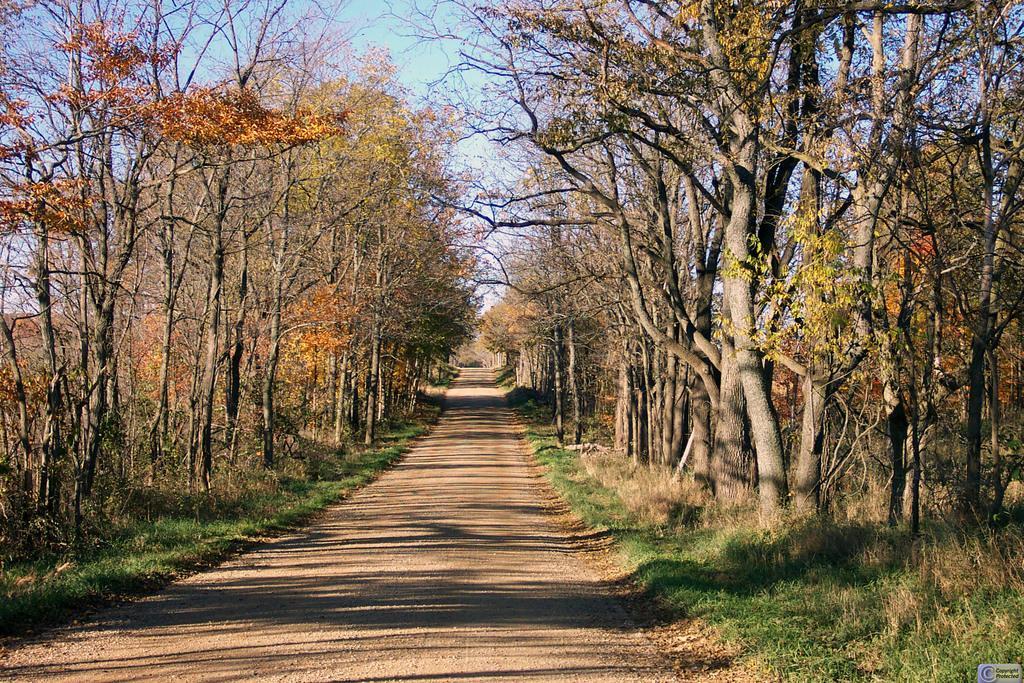Please provide a concise description of this image. In this image I can see the road. I can see some grass and few trees which are green and orange in color on both sides of the road. In the background I can see the sky. 